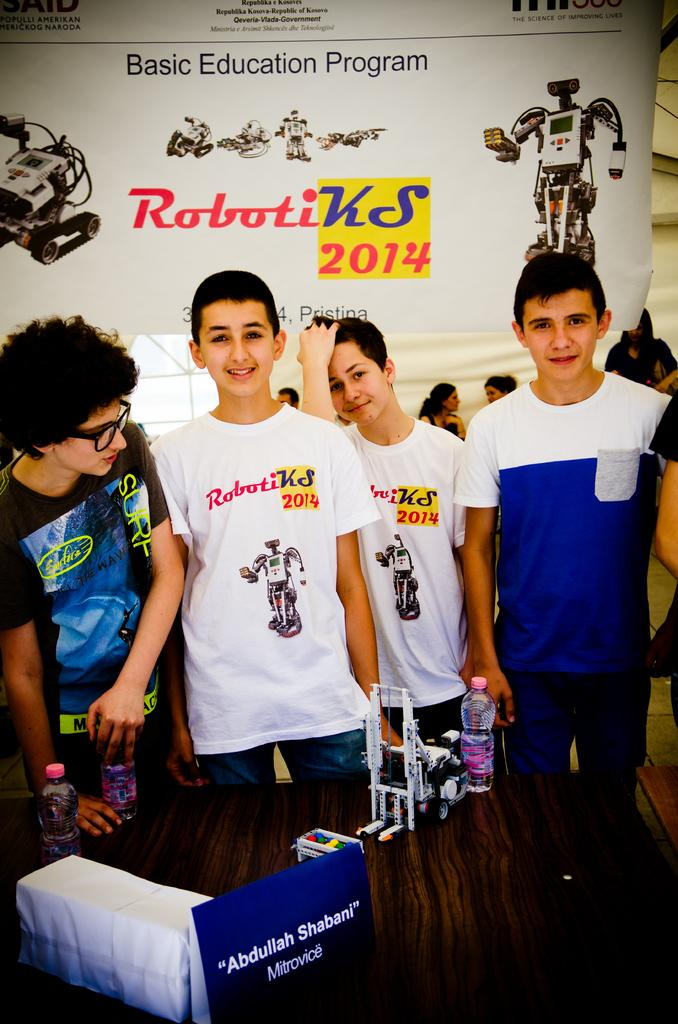<image>
Describe the image concisely. A group of boys at a Roboti KS 2014 Education program event. 